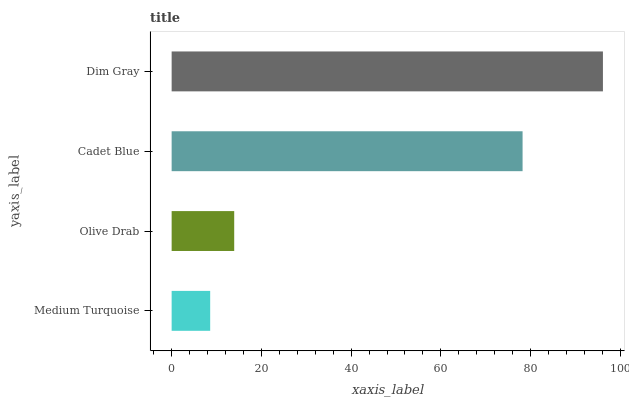Is Medium Turquoise the minimum?
Answer yes or no. Yes. Is Dim Gray the maximum?
Answer yes or no. Yes. Is Olive Drab the minimum?
Answer yes or no. No. Is Olive Drab the maximum?
Answer yes or no. No. Is Olive Drab greater than Medium Turquoise?
Answer yes or no. Yes. Is Medium Turquoise less than Olive Drab?
Answer yes or no. Yes. Is Medium Turquoise greater than Olive Drab?
Answer yes or no. No. Is Olive Drab less than Medium Turquoise?
Answer yes or no. No. Is Cadet Blue the high median?
Answer yes or no. Yes. Is Olive Drab the low median?
Answer yes or no. Yes. Is Medium Turquoise the high median?
Answer yes or no. No. Is Dim Gray the low median?
Answer yes or no. No. 